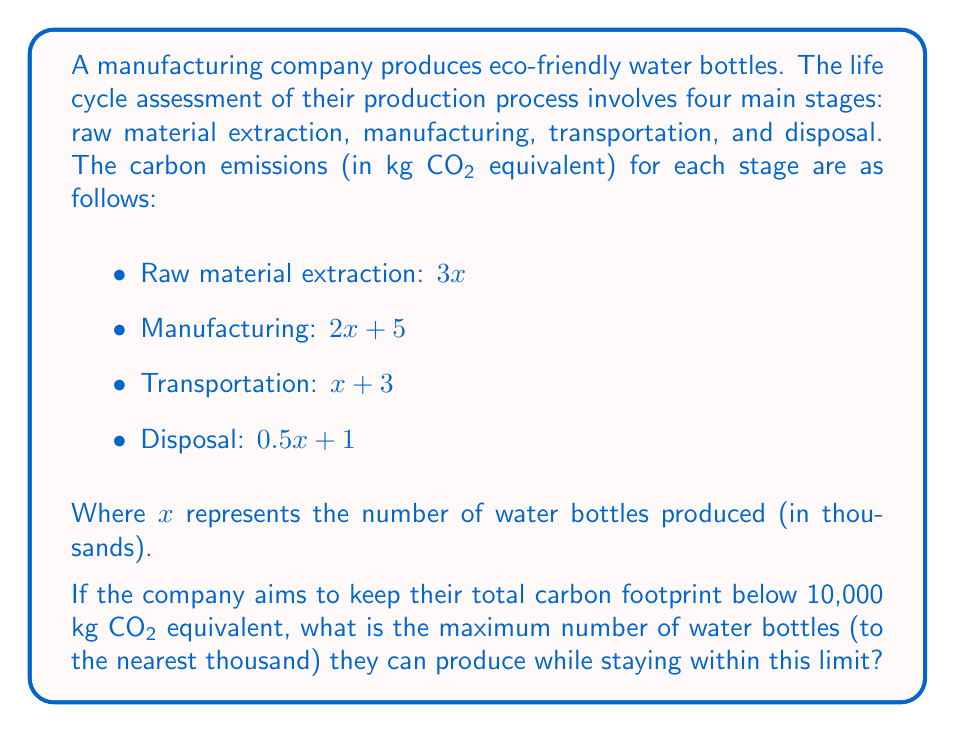Provide a solution to this math problem. To solve this problem, we need to follow these steps:

1) First, let's express the total carbon footprint as a function of $x$:

   Total carbon footprint = Raw material extraction + Manufacturing + Transportation + Disposal
   $$f(x) = (3x) + (2x + 5) + (x + 3) + (0.5x + 1)$$

2) Simplify the equation:
   $$f(x) = 3x + 2x + 5 + x + 3 + 0.5x + 1$$
   $$f(x) = 6.5x + 9$$

3) We want to find the maximum value of $x$ where $f(x)$ is still less than 10,000:
   $$6.5x + 9 < 10,000$$

4) Solve the inequality:
   $$6.5x < 9,991$$
   $$x < 1,536.3077$$

5) Since $x$ represents thousands of water bottles, and we need to round down to stay below the limit, the maximum value of $x$ is 1,536.

6) Convert back to actual number of water bottles:
   1,536 * 1,000 = 1,536,000

Therefore, the company can produce a maximum of 1,536,000 water bottles while keeping their carbon footprint below 10,000 kg CO₂ equivalent.
Answer: 1,536,000 water bottles 